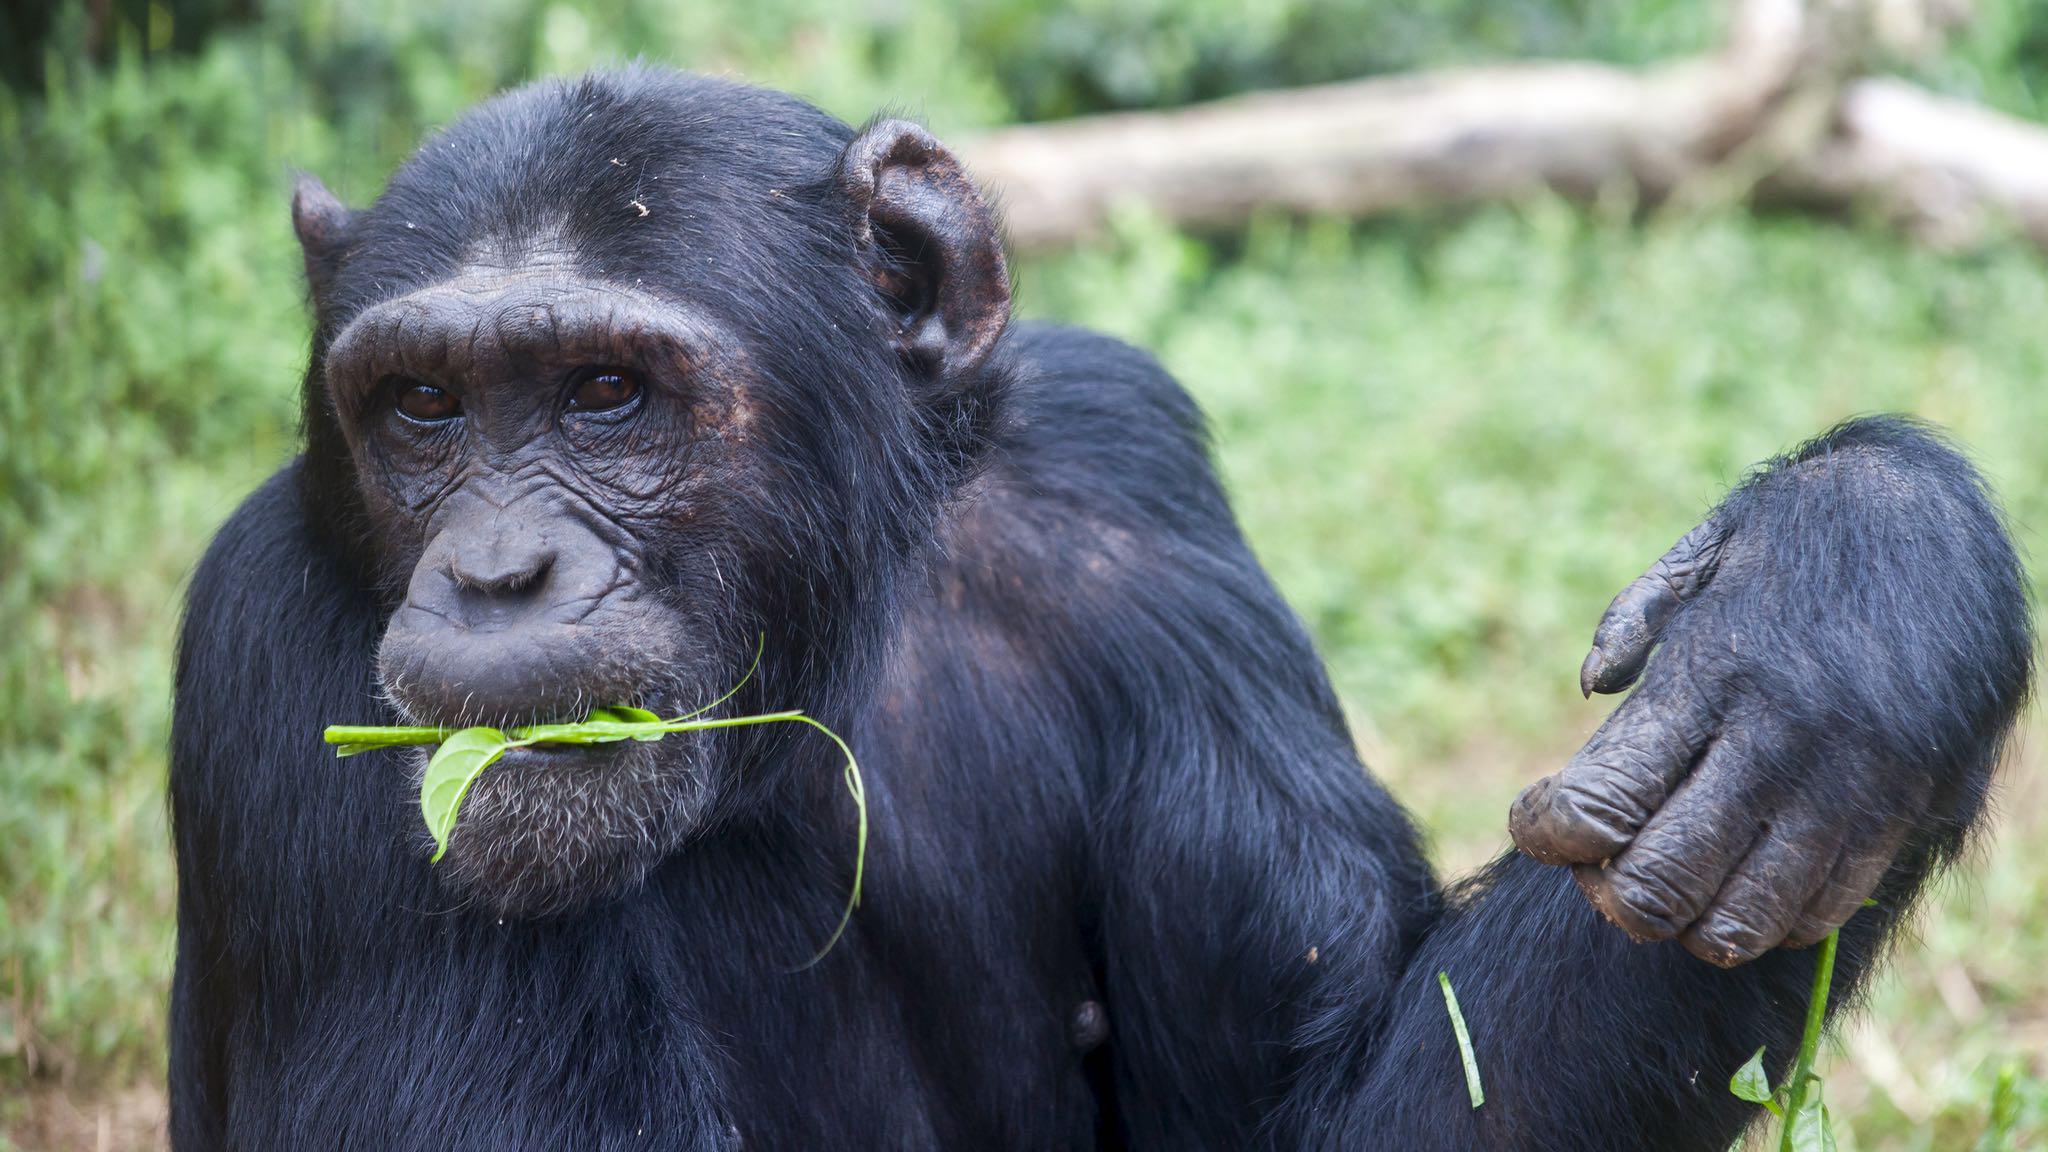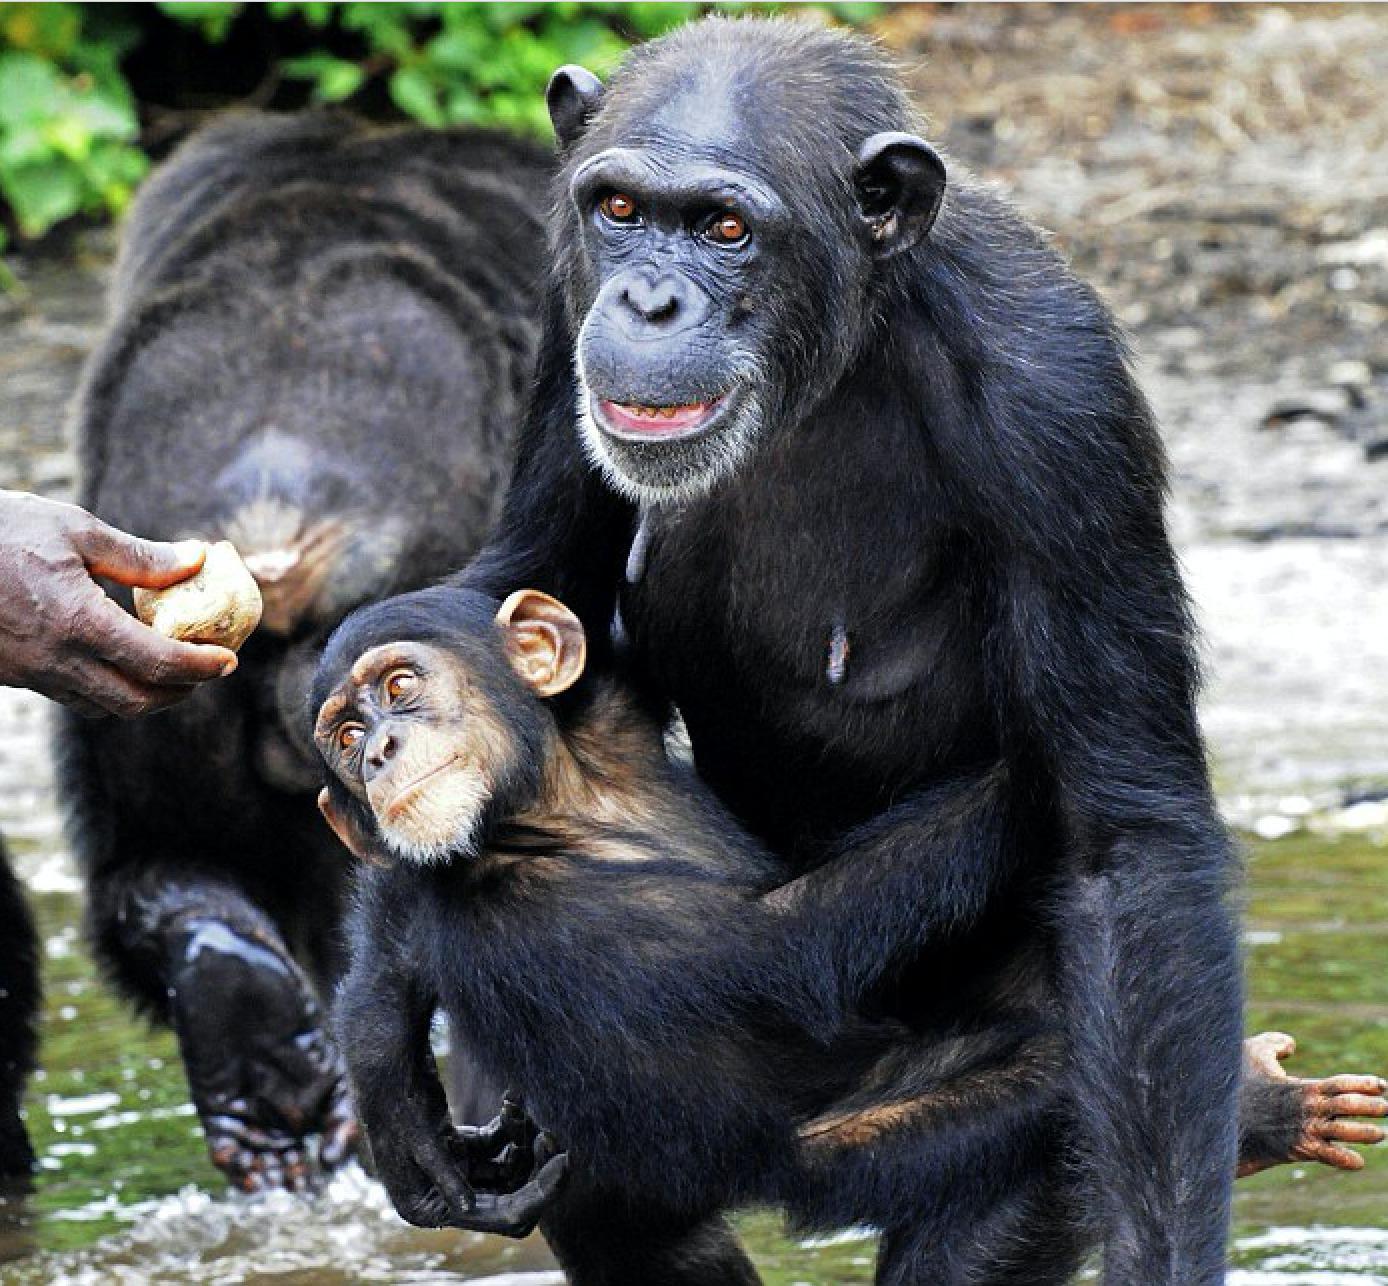The first image is the image on the left, the second image is the image on the right. Analyze the images presented: Is the assertion "There is a baby monkey being held by its mother." valid? Answer yes or no. Yes. The first image is the image on the left, the second image is the image on the right. Analyze the images presented: Is the assertion "One chimp is holding another chimp." valid? Answer yes or no. Yes. 